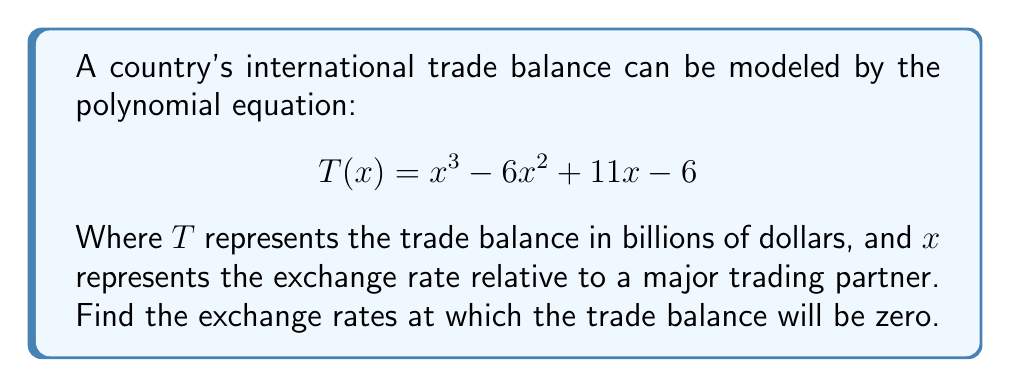Teach me how to tackle this problem. To find the exchange rates where the trade balance is zero, we need to find the roots of the polynomial equation $T(x) = 0$. Let's solve this step-by-step:

1) Set the equation equal to zero:
   $$x^3 - 6x^2 + 11x - 6 = 0$$

2) This is a cubic equation. One way to solve it is by factoring. Let's try to guess one factor first. We can see that when $x = 1$, $T(1) = 1 - 6 + 11 - 6 = 0$. So $(x - 1)$ is a factor.

3) Divide the polynomial by $(x - 1)$:
   $$x^3 - 6x^2 + 11x - 6 = (x - 1)(x^2 - 5x + 6)$$

4) Now we have reduced it to a quadratic equation: $x^2 - 5x + 6 = 0$

5) We can solve this using the quadratic formula: $x = \frac{-b \pm \sqrt{b^2 - 4ac}}{2a}$
   Where $a = 1$, $b = -5$, and $c = 6$

6) Plugging into the formula:
   $$x = \frac{5 \pm \sqrt{25 - 24}}{2} = \frac{5 \pm 1}{2}$$

7) This gives us two more solutions: $x = 3$ and $x = 2$

Therefore, the complete factorization is:
$$T(x) = (x - 1)(x - 2)(x - 3)$$
Answer: The exchange rates at which the trade balance will be zero are $x = 1$, $x = 2$, and $x = 3$. 